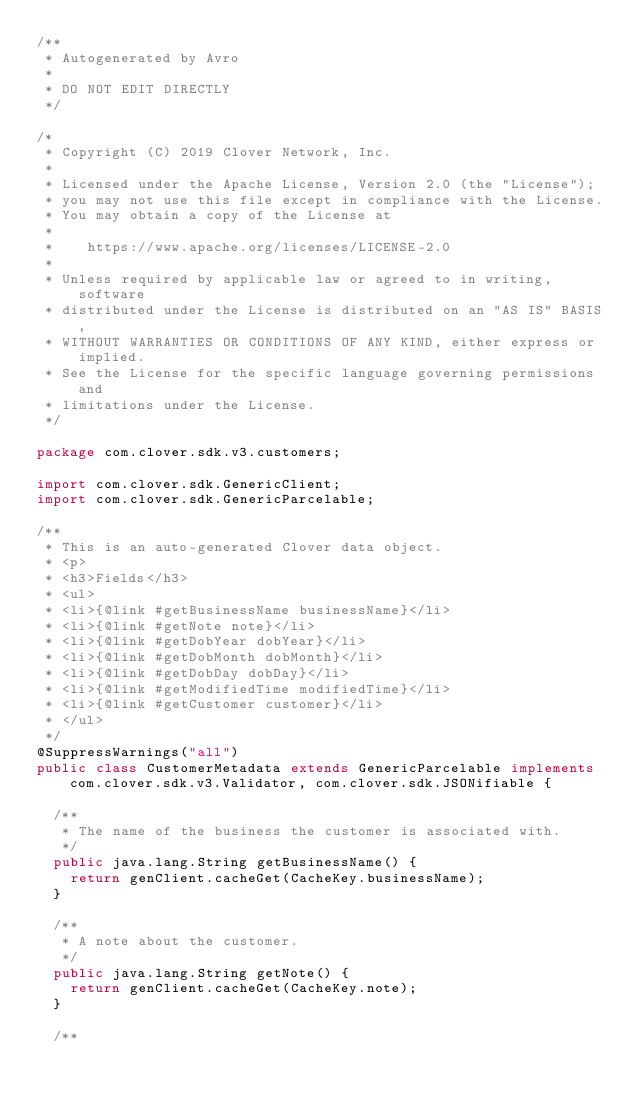<code> <loc_0><loc_0><loc_500><loc_500><_Java_>/**
 * Autogenerated by Avro
 * 
 * DO NOT EDIT DIRECTLY
 */

/*
 * Copyright (C) 2019 Clover Network, Inc.
 *
 * Licensed under the Apache License, Version 2.0 (the "License");
 * you may not use this file except in compliance with the License.
 * You may obtain a copy of the License at
 *
 *    https://www.apache.org/licenses/LICENSE-2.0
 *
 * Unless required by applicable law or agreed to in writing, software
 * distributed under the License is distributed on an "AS IS" BASIS,
 * WITHOUT WARRANTIES OR CONDITIONS OF ANY KIND, either express or implied.
 * See the License for the specific language governing permissions and
 * limitations under the License.
 */

package com.clover.sdk.v3.customers;

import com.clover.sdk.GenericClient;
import com.clover.sdk.GenericParcelable;

/**
 * This is an auto-generated Clover data object.
 * <p>
 * <h3>Fields</h3>
 * <ul>
 * <li>{@link #getBusinessName businessName}</li>
 * <li>{@link #getNote note}</li>
 * <li>{@link #getDobYear dobYear}</li>
 * <li>{@link #getDobMonth dobMonth}</li>
 * <li>{@link #getDobDay dobDay}</li>
 * <li>{@link #getModifiedTime modifiedTime}</li>
 * <li>{@link #getCustomer customer}</li>
 * </ul>
 */
@SuppressWarnings("all")
public class CustomerMetadata extends GenericParcelable implements com.clover.sdk.v3.Validator, com.clover.sdk.JSONifiable {

  /**
   * The name of the business the customer is associated with.
   */
  public java.lang.String getBusinessName() {
    return genClient.cacheGet(CacheKey.businessName);
  }

  /**
   * A note about the customer.
   */
  public java.lang.String getNote() {
    return genClient.cacheGet(CacheKey.note);
  }

  /**</code> 